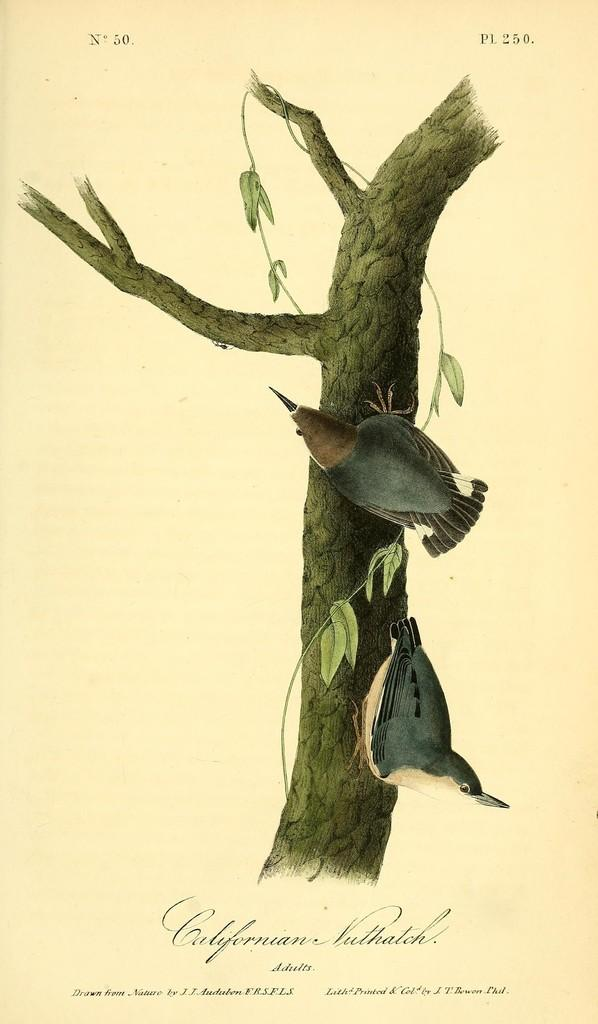What type of visual is the image? The image is a poster. What can be seen in the image besides the text? There are two birds on a tree in the image. What is the purpose of the text on the image? The text on the image provides additional information or context. Where is the writer of the text in the image? There is no writer present in the image, as the text is likely printed or pre-written. 